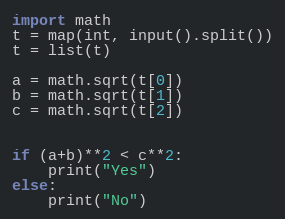<code> <loc_0><loc_0><loc_500><loc_500><_Python_>import math
t = map(int, input().split())
t = list(t)

a = math.sqrt(t[0])
b = math.sqrt(t[1])
c = math.sqrt(t[2])


if (a+b)**2 < c**2:
    print("Yes")
else:
    print("No")</code> 